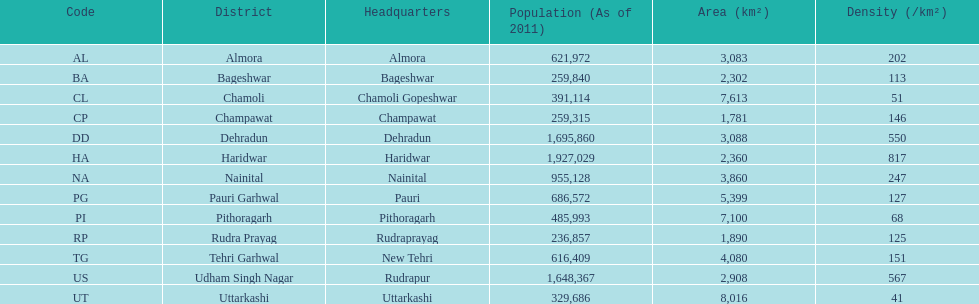What is the overall number of districts mentioned? 13. 